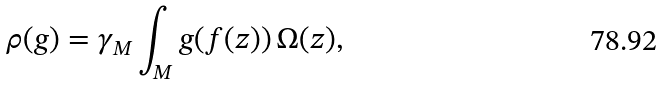<formula> <loc_0><loc_0><loc_500><loc_500>\rho ( g ) = \gamma _ { M } \int _ { M } g ( f ( z ) ) \, \Omega ( z ) ,</formula> 